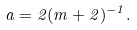Convert formula to latex. <formula><loc_0><loc_0><loc_500><loc_500>\ a = 2 ( m + 2 ) ^ { - 1 } .</formula> 